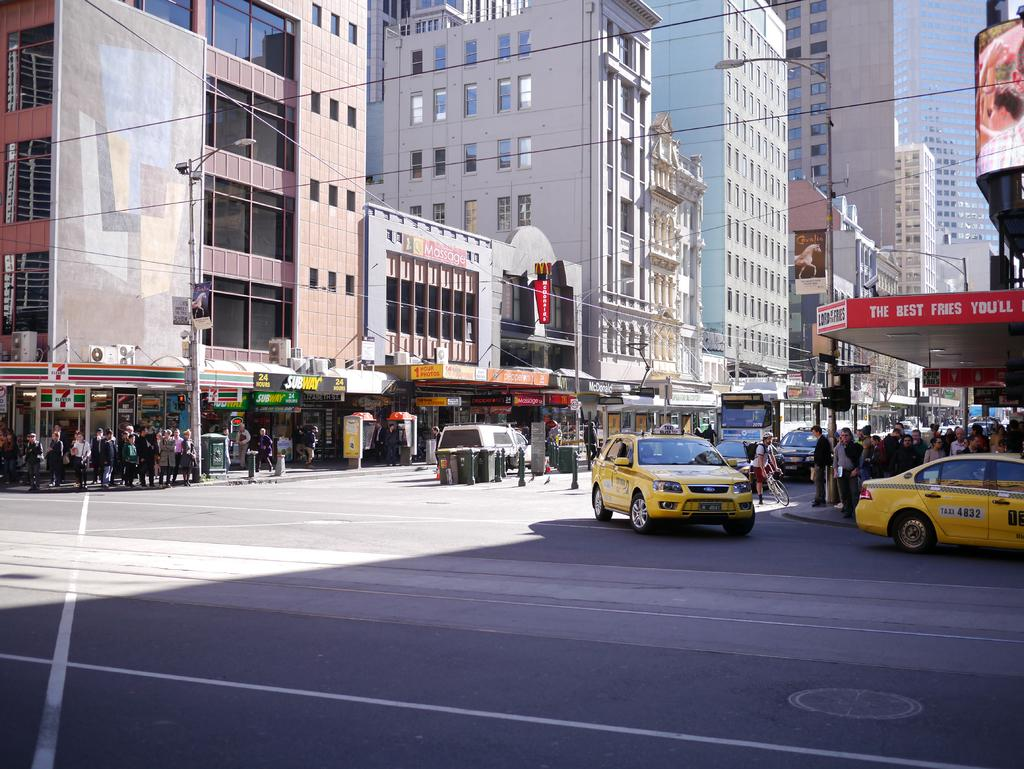<image>
Summarize the visual content of the image. A busy intersection has taxis driving by under a sign that says The Best Fries You'll. 